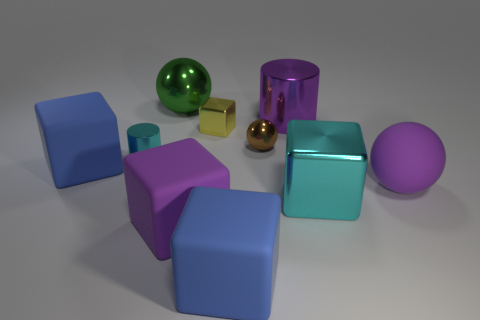Subtract all big purple cylinders. Subtract all shiny things. How many objects are left? 3 Add 2 big matte blocks. How many big matte blocks are left? 5 Add 4 small things. How many small things exist? 7 Subtract all purple cylinders. How many cylinders are left? 1 Subtract all big blue blocks. How many blocks are left? 3 Subtract 0 green blocks. How many objects are left? 10 Subtract all cylinders. How many objects are left? 8 Subtract 1 spheres. How many spheres are left? 2 Subtract all purple cubes. Subtract all red cylinders. How many cubes are left? 4 Subtract all purple cylinders. How many purple balls are left? 1 